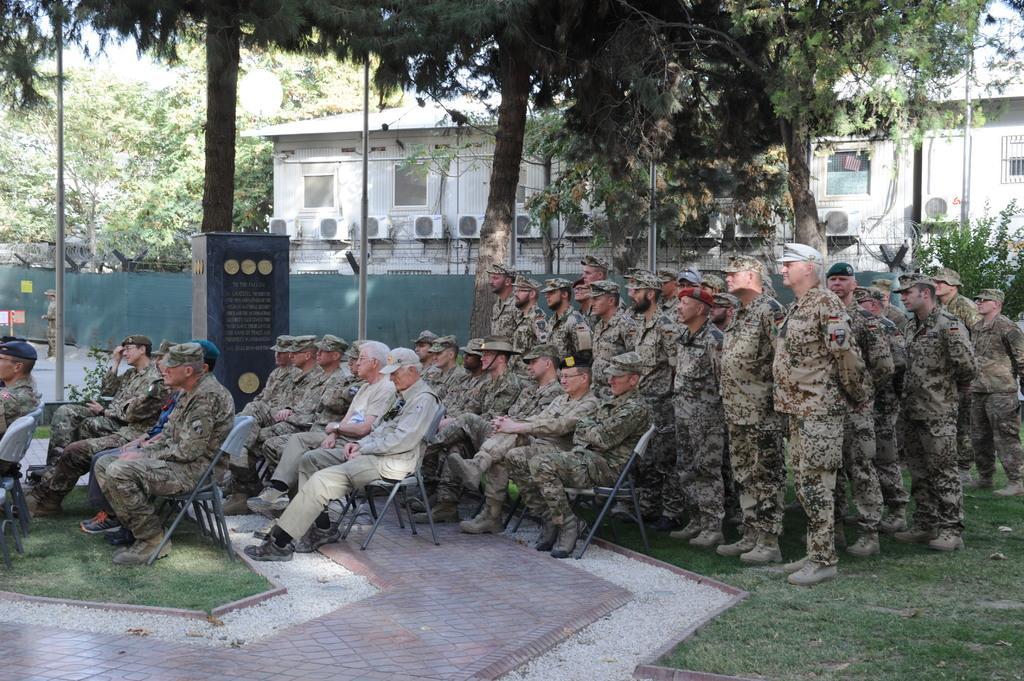In one or two sentences, can you explain what this image depicts? In this image there are a few army personnel sitting in chairs, behind them there are a few army personnel standing, beside them there are trees, plants and poles, sign boards, a structure with some text on it, a barbed wire fence covered with a cloth, on the other side of the fence there is a building and trees. 